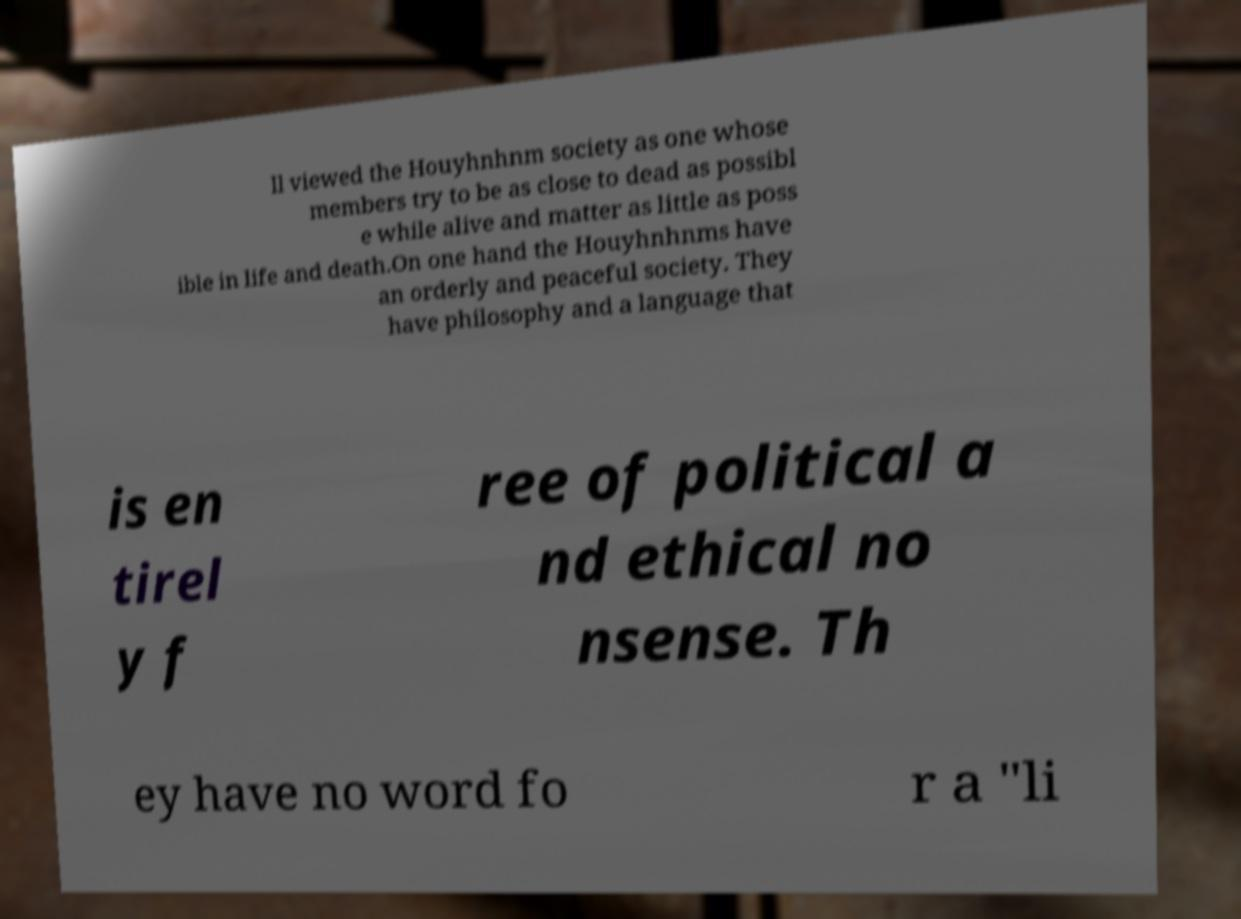Please identify and transcribe the text found in this image. ll viewed the Houyhnhnm society as one whose members try to be as close to dead as possibl e while alive and matter as little as poss ible in life and death.On one hand the Houyhnhnms have an orderly and peaceful society. They have philosophy and a language that is en tirel y f ree of political a nd ethical no nsense. Th ey have no word fo r a "li 